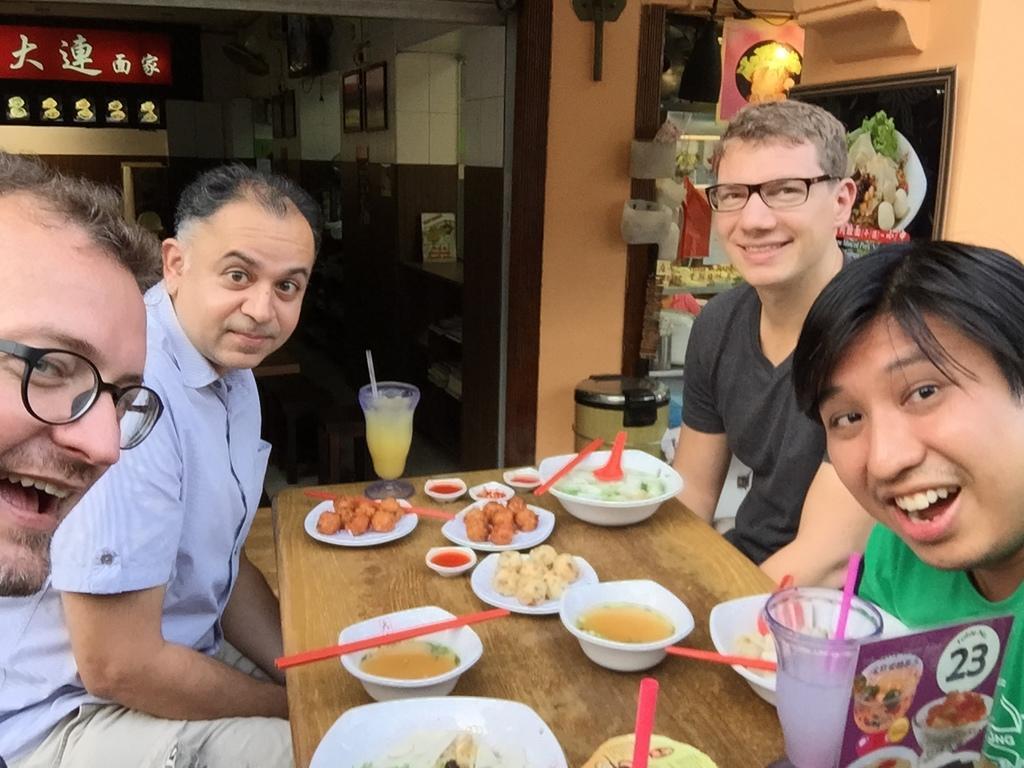Can you describe this image briefly? In this picture I can see some people are sitting in front of the table, on which we can see some food items are placed and also we can see some glasses, behind we can see a shop on which we can see some objects. 